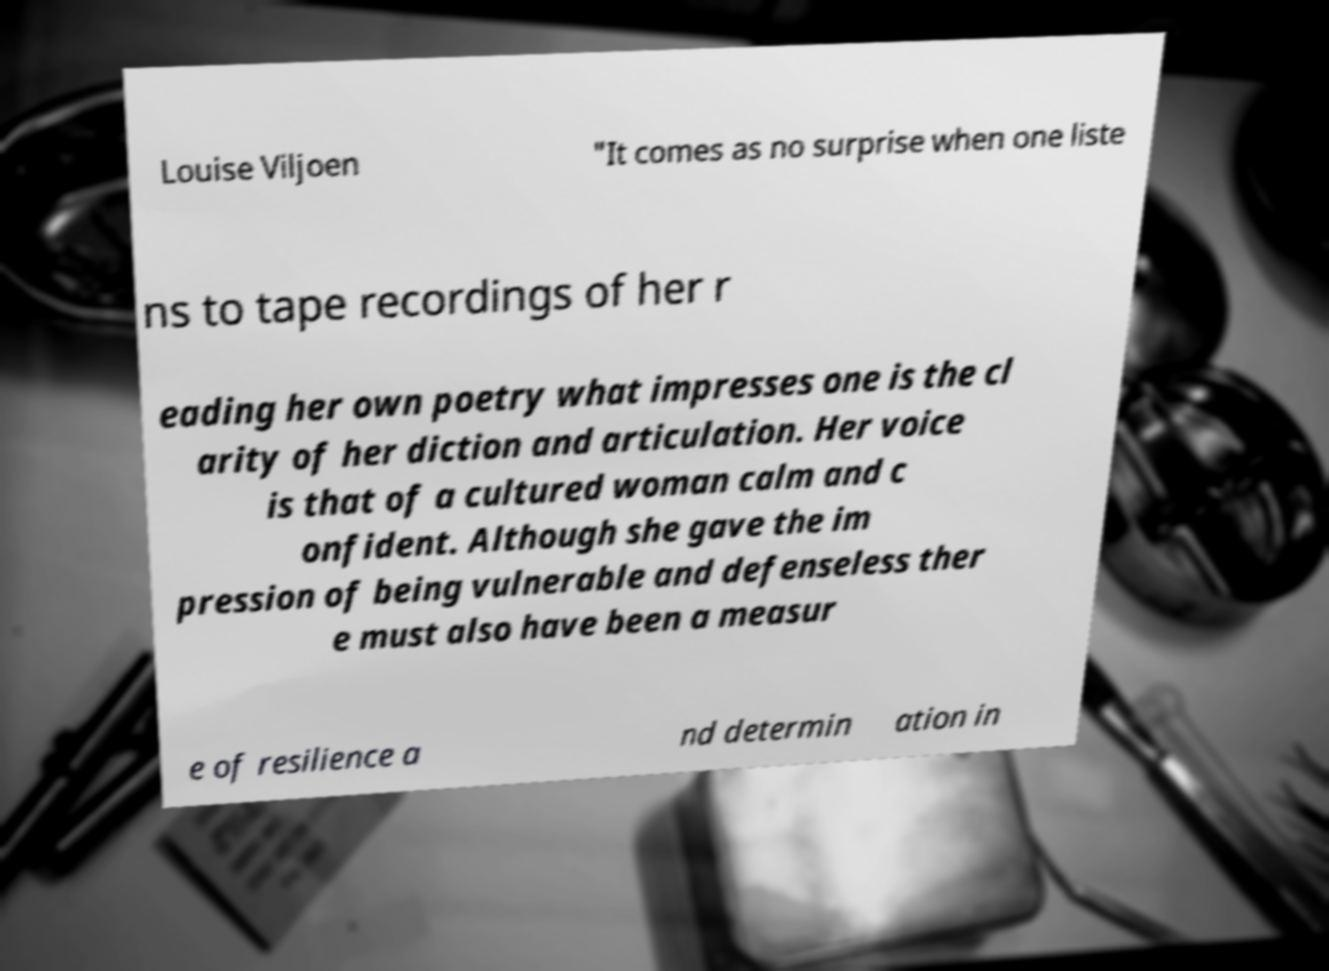For documentation purposes, I need the text within this image transcribed. Could you provide that? Louise Viljoen "It comes as no surprise when one liste ns to tape recordings of her r eading her own poetry what impresses one is the cl arity of her diction and articulation. Her voice is that of a cultured woman calm and c onfident. Although she gave the im pression of being vulnerable and defenseless ther e must also have been a measur e of resilience a nd determin ation in 